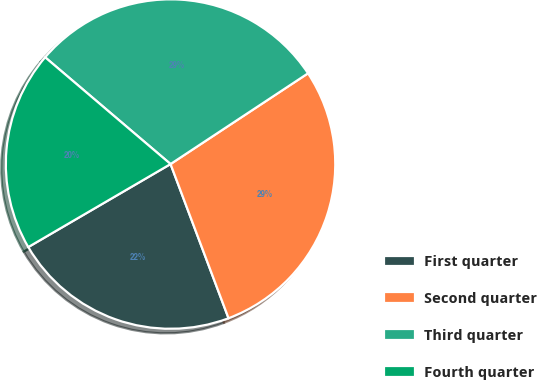Convert chart. <chart><loc_0><loc_0><loc_500><loc_500><pie_chart><fcel>First quarter<fcel>Second quarter<fcel>Third quarter<fcel>Fourth quarter<nl><fcel>22.32%<fcel>28.56%<fcel>29.49%<fcel>19.63%<nl></chart> 